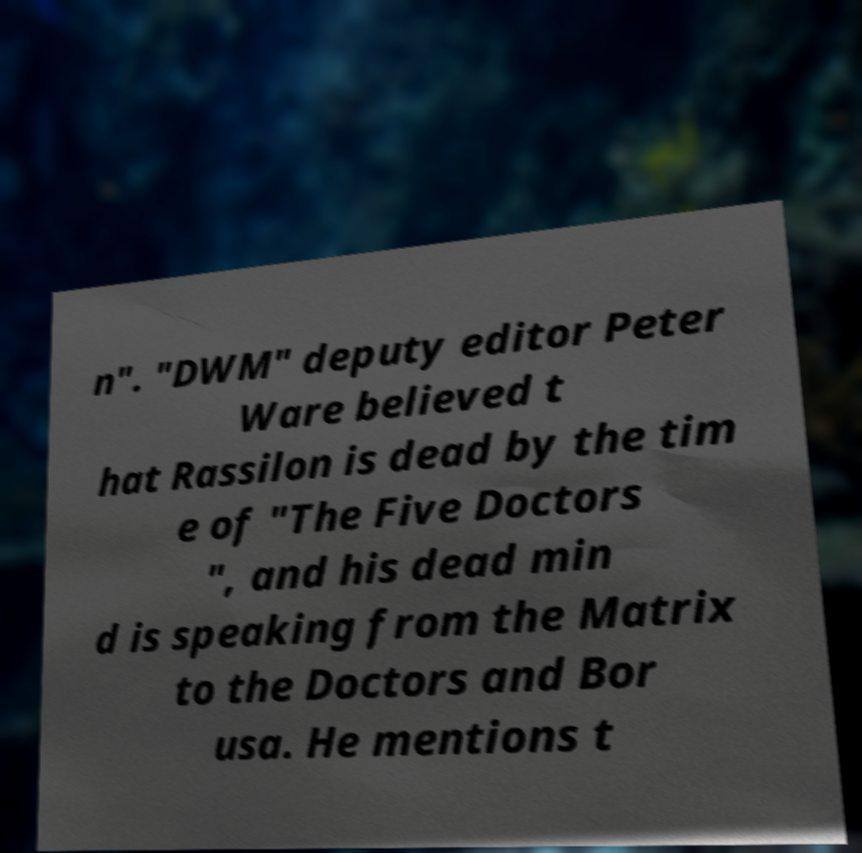Please identify and transcribe the text found in this image. n". "DWM" deputy editor Peter Ware believed t hat Rassilon is dead by the tim e of "The Five Doctors ", and his dead min d is speaking from the Matrix to the Doctors and Bor usa. He mentions t 